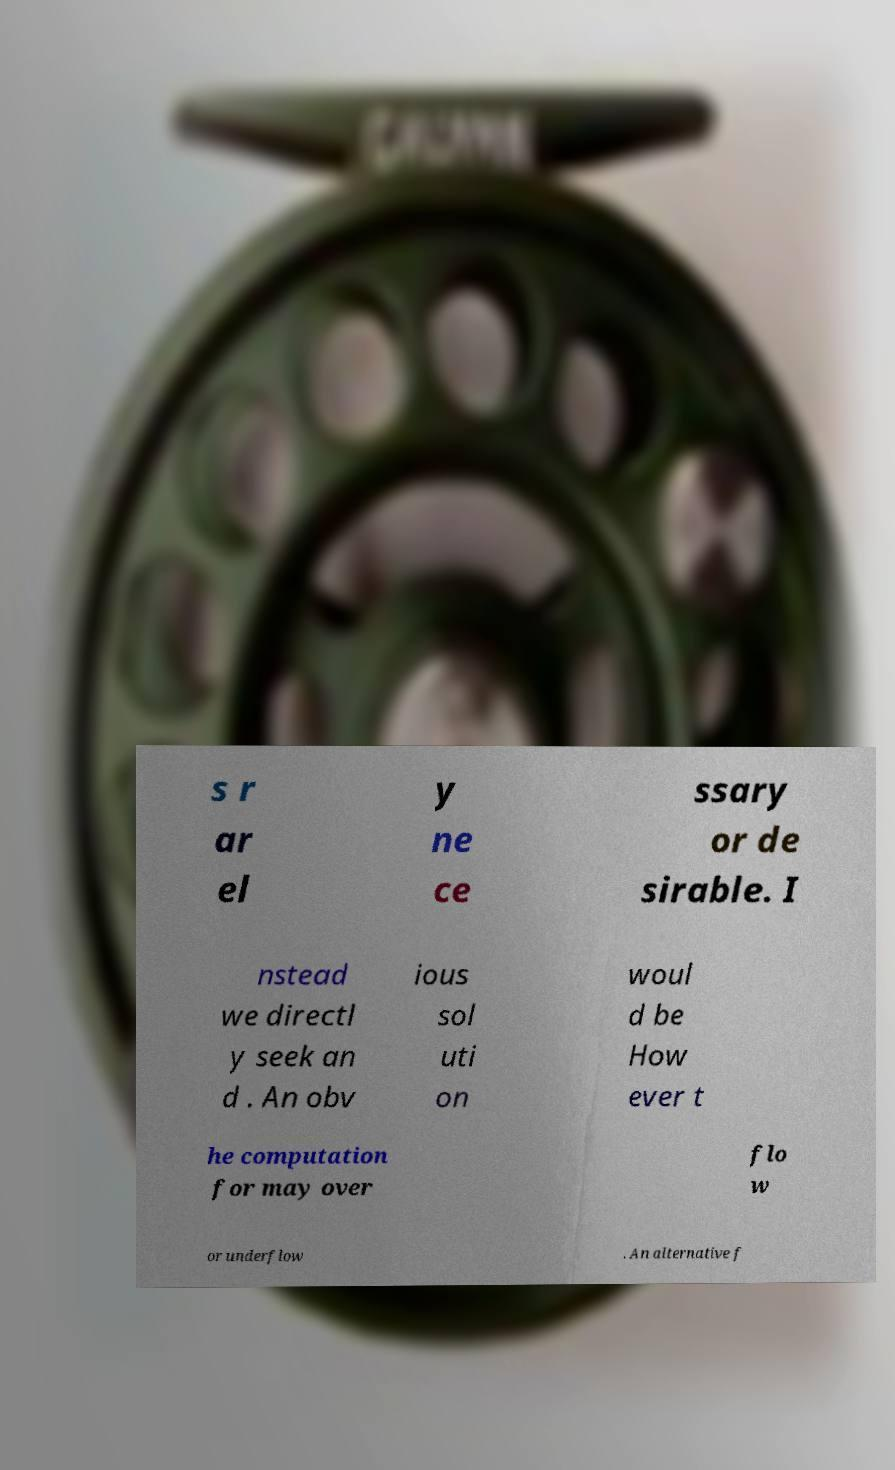Please read and relay the text visible in this image. What does it say? s r ar el y ne ce ssary or de sirable. I nstead we directl y seek an d . An obv ious sol uti on woul d be How ever t he computation for may over flo w or underflow . An alternative f 